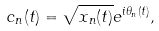<formula> <loc_0><loc_0><loc_500><loc_500>c _ { n } ( t ) = \sqrt { x _ { n } ( t ) } e ^ { i \theta _ { n } ( t ) } ,</formula> 